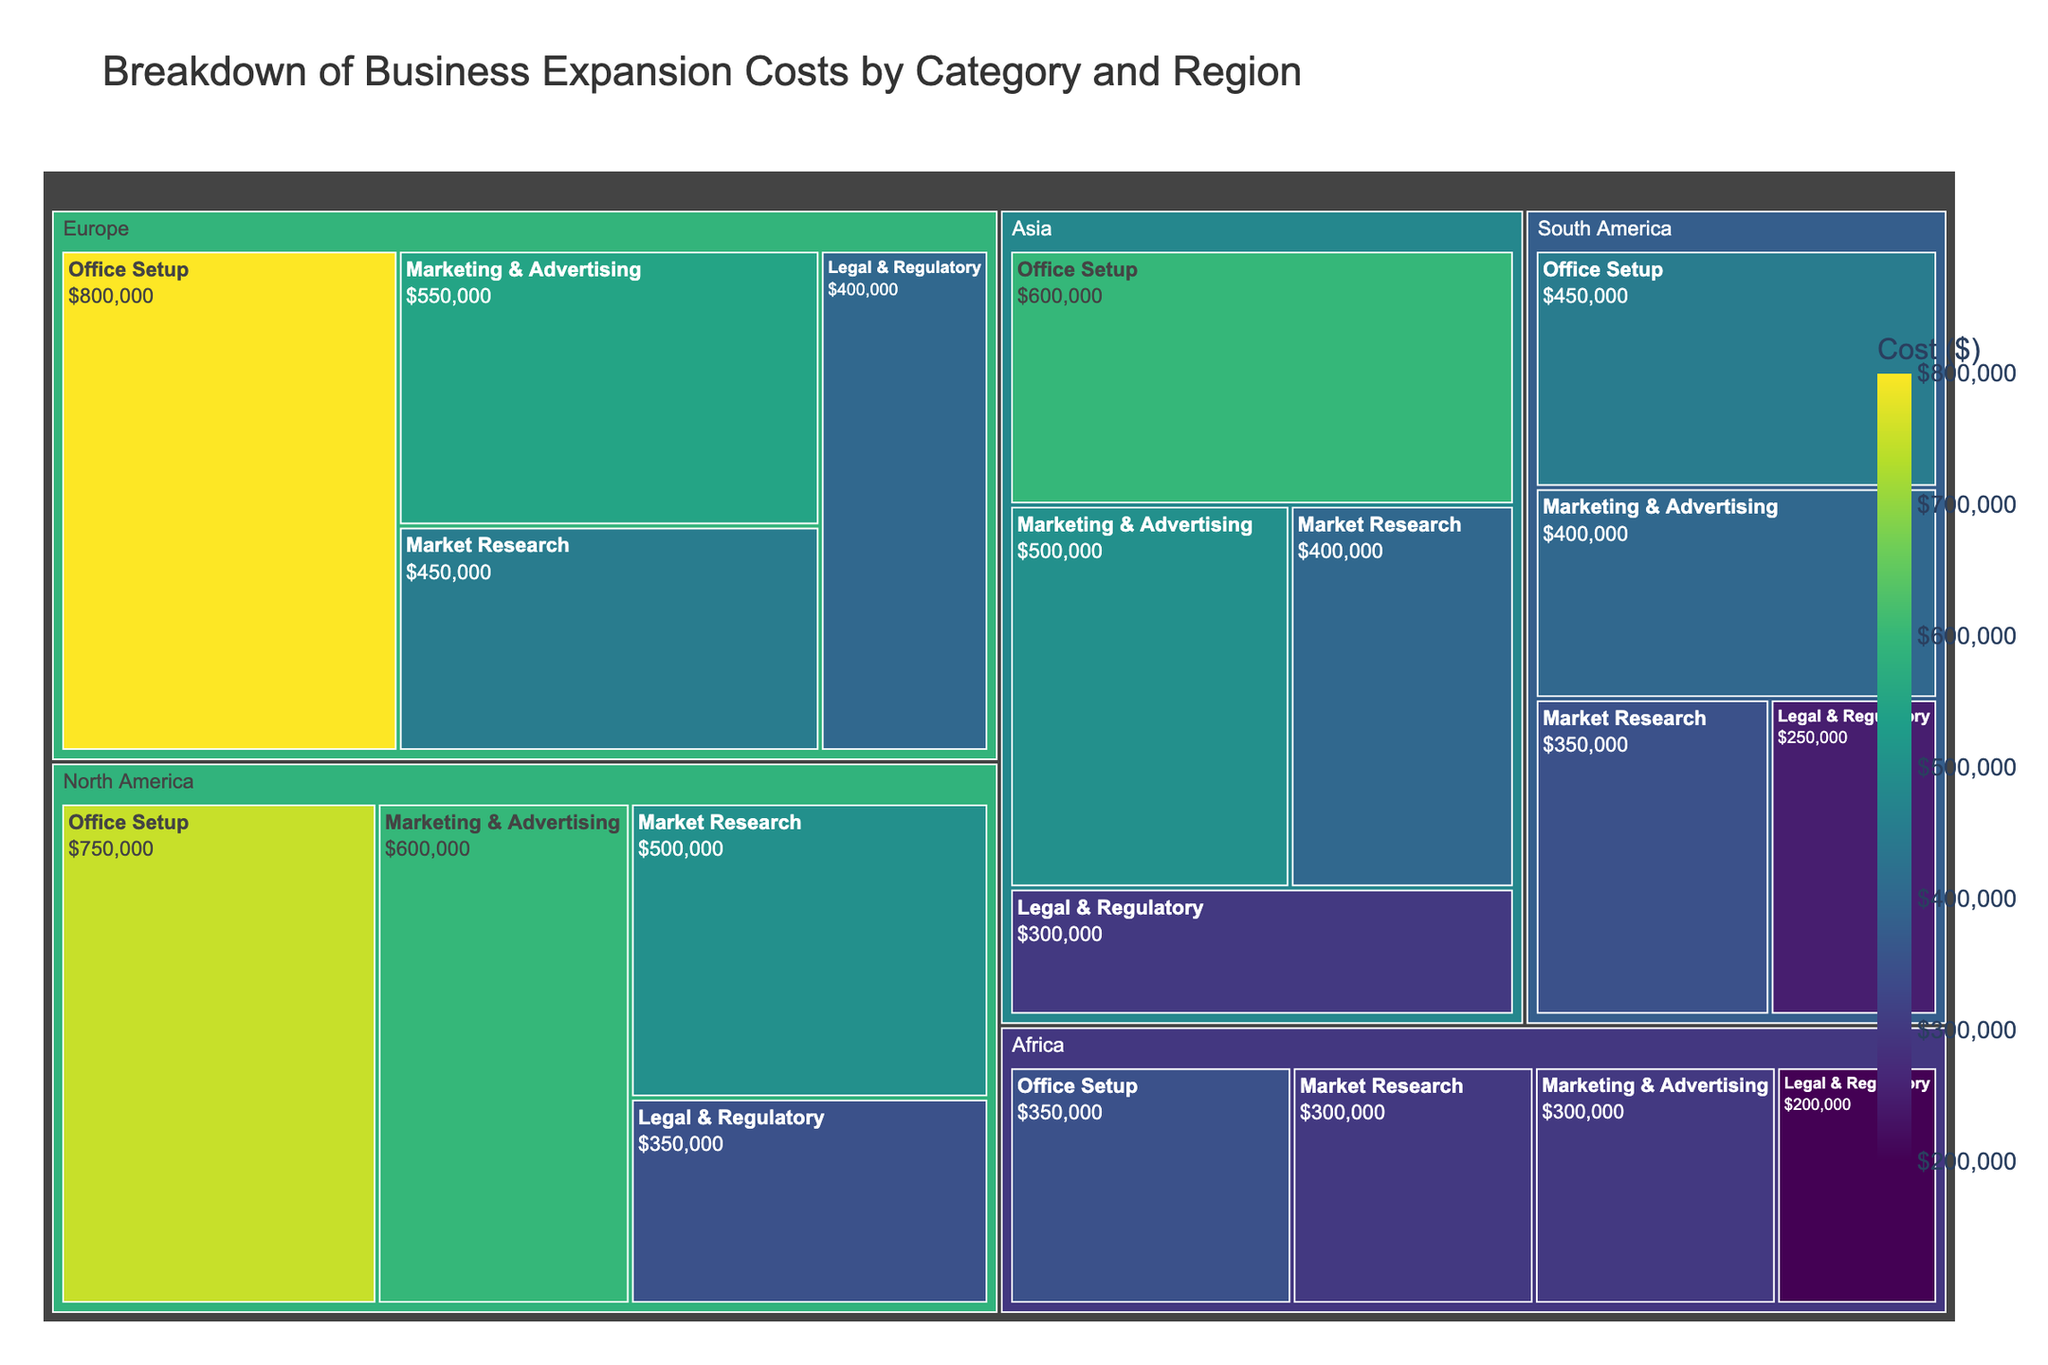What is the title of the Treemap? The title is displayed at the top of the Treemap and provides context for the data being visualized.
Answer: Breakdown of Business Expansion Costs by Category and Region Which region has the highest total expansion cost? By observing the area of each region in the Treemap, we can see that North America has the largest combined area, indicating it has the highest total cost.
Answer: North America What is the cost for Office Setup in Europe? Navigate to Europe on the Treemap, then look at the section for Office Setup. The cost is shown directly inside the box.
Answer: $800,000 What is the combined cost of Market Research in North America and Europe? Find the Market Research costs for North America ($500,000) and Europe ($450,000), then sum them up: $500,000 + $450,000 = $950,000.
Answer: $950,000 Which category has the lowest cost in Asia? Look at the different categories within the Asia region. The smallest area, which corresponds to the lowest cost, is Legal & Regulatory at $300,000.
Answer: Legal & Regulatory How does the Marketing & Advertising cost in South America compare to that in Africa? Identify the Marketing & Advertising sections for South America ($400,000) and Africa ($300,000) and compare them. South America has a higher cost.
Answer: South America has a higher cost What's the total cost for Legal & Regulatory in all regions combined? Add the Legal & Regulatory costs from all regions: $350,000 (North America) + $400,000 (Europe) + $300,000 (Asia) + $250,000 (South America) + $200,000 (Africa) = $1,500,000.
Answer: $1,500,000 Which region has the smallest Market Research expenditure, and what is that amount? Examine the Market Research expenditures for all regions. Africa has the smallest amount at $300,000.
Answer: Africa, $300,000 How does the total expansion cost of Africa compare to Asia? Calculate the total cost for each region: Africa ($300,000 + $200,000 + $350,000 + $300,000 = $1,150,000) and Asia ($400,000 + $300,000 + $600,000 + $500,000 = $1,800,000). Asia has a higher total cost.
Answer: Asia has a higher total cost What's the average cost of Marketing & Advertising across all regions? Add the Marketing & Advertising costs for all regions and divide by the number of regions: ($600,000 + $550,000 + $500,000 + $400,000 + $300,000) / 5 = $470,000.
Answer: $470,000 